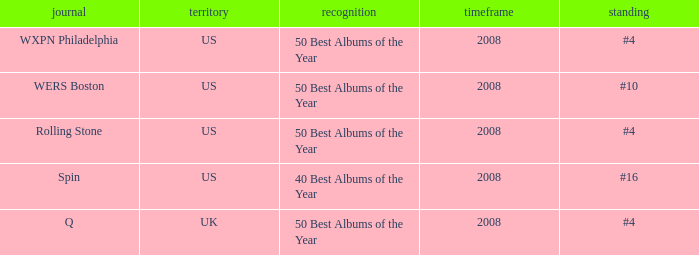Which rank's country is the US when the accolade is 40 best albums of the year? #16. 